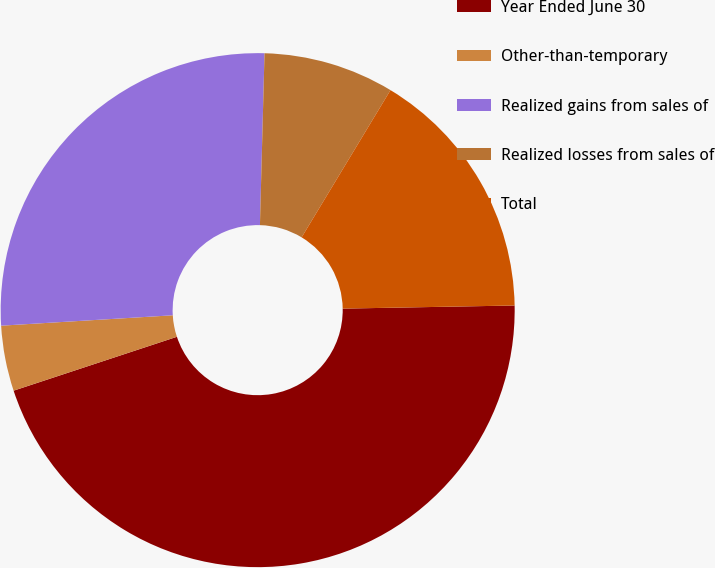Convert chart to OTSL. <chart><loc_0><loc_0><loc_500><loc_500><pie_chart><fcel>Year Ended June 30<fcel>Other-than-temporary<fcel>Realized gains from sales of<fcel>Realized losses from sales of<fcel>Total<nl><fcel>45.22%<fcel>4.11%<fcel>26.39%<fcel>8.22%<fcel>16.07%<nl></chart> 